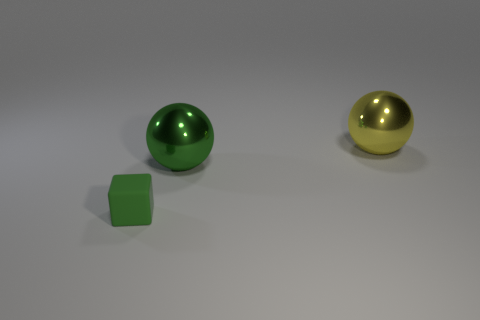Subtract 1 balls. How many balls are left? 1 Add 2 large brown rubber objects. How many objects exist? 5 Subtract all cubes. How many objects are left? 2 Subtract all yellow balls. Subtract all cyan cylinders. How many balls are left? 1 Subtract all blue cubes. How many cyan balls are left? 0 Subtract all green rubber objects. Subtract all tiny green cubes. How many objects are left? 1 Add 2 matte objects. How many matte objects are left? 3 Add 2 small cylinders. How many small cylinders exist? 2 Subtract 0 cyan cubes. How many objects are left? 3 